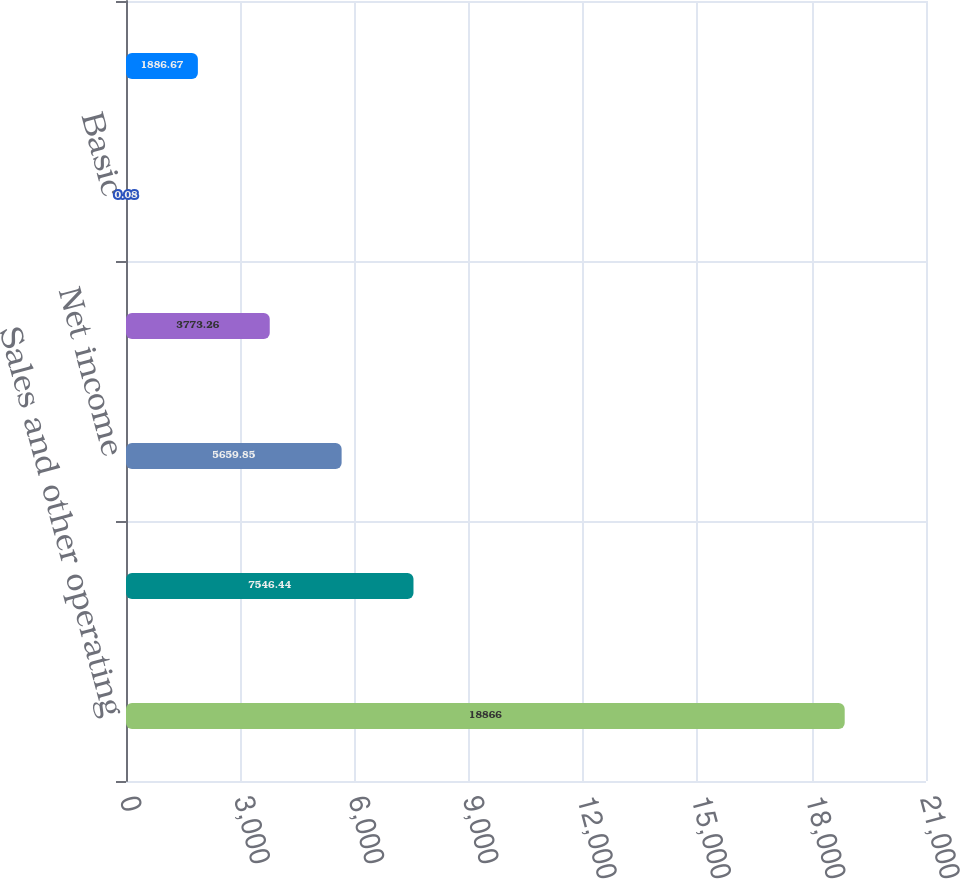Convert chart. <chart><loc_0><loc_0><loc_500><loc_500><bar_chart><fcel>Sales and other operating<fcel>Income from operations<fcel>Net income<fcel>Net income attributable to MPC<fcel>Basic<fcel>Diluted<nl><fcel>18866<fcel>7546.44<fcel>5659.85<fcel>3773.26<fcel>0.08<fcel>1886.67<nl></chart> 